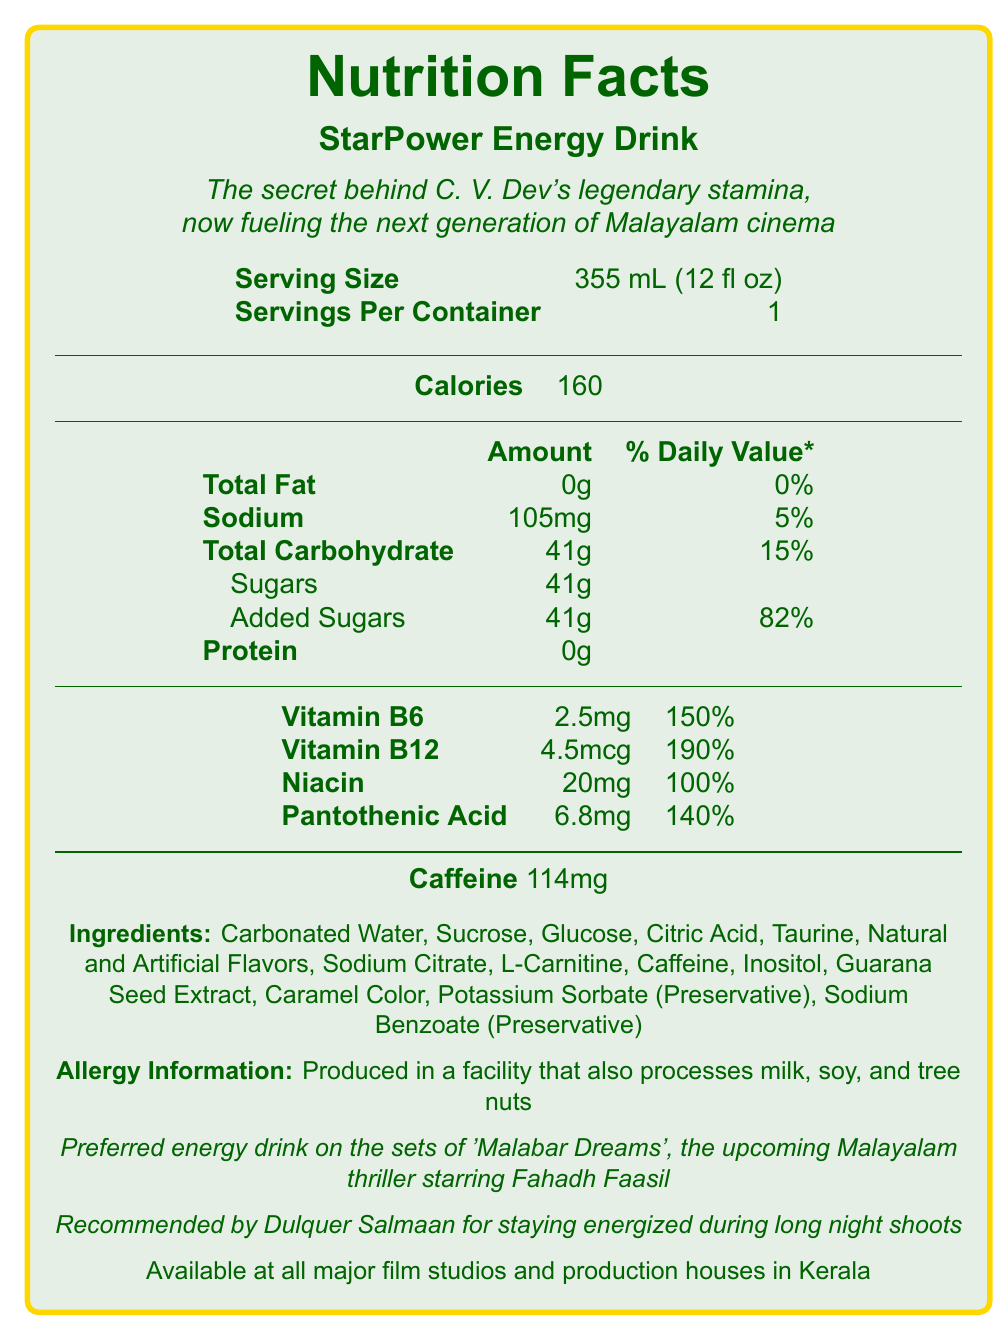what is the serving size of the StarPower Energy Drink? The serving size is mentioned under the section "Serving Size" in the document.
Answer: 355 mL (12 fl oz) how many calories are in one serving of StarPower Energy Drink? The calorie count is listed as "Calories: 160" in the document.
Answer: 160 calories what percentage of the daily value for sodium is in one serving? The sodium content shows "105mg" with a daily value of "5%" in the document.
Answer: 5% what is the amount of added sugars in the energy drink? Under the "Sugars" section, it specifies that "Added Sugars" amount to "41g".
Answer: 41g how much caffeine does one serving contain? The caffeine content is clearly listed as "Caffeine 114mg" in the document.
Answer: 114mg which Vitamin has the highest percentage of daily value? Vitamin B12 has the highest daily value percentage at "190%" in the list provided.
Answer: Vitamin B12 which of the following ingredients are preservatives? A. Taurine B. Potassium Sorbate C. L-Carnitine D. Inositol The document lists Potassium Sorbate as a preservative, under "Ingredients".
Answer: B. Potassium Sorbate what is the main reason for the energy drink's popularity in the Malayalam film industry? A. It's affordable B. Preferred on the sets of 'Malabar Dreams' C. Endorsed by a dietitian D. Available in every supermarket The document states the energy drink is "Preferred on the sets of 'Malabar Dreams'" and also endorsed by Dulquer Salmaan, making it popular.
Answer: B. Preferred on the sets of 'Malabar Dreams' is the StarPower Energy Drink recommended by a celebrity? The document mentions that it is "Recommended by Dulquer Salmaan for staying energized during long night shoots".
Answer: Yes summarize the main features and information of the StarPower Energy Drink. This summary encapsulates the essential details and unique features of the energy drink, emphasizing its popularity in the Malayalam film industry, nutritional content, ingredients, and allergy information.
Answer: The StarPower Energy Drink is a popular choice among filmmakers in Kerala, preferred on the sets of 'Malabar Dreams' and recommended by Dulquer Salmaan. The drink provides 160 calories per 355 mL serving and contains 0g total fat, 105mg sodium, 41g total carbohydrates, and 0g protein. It also contains 114mg of caffeine and a variety of vitamins and minerals, such as Vitamin B6, B12, Niacin, and Pantothenic Acid. The ingredients include carbonated water, sucrose, glucose, citric acid, among others. It is produced in a facility that processes milk, soy, and tree nuts. is the energy drink suitable for people with a milk allergy? The document states that the drink is produced in a facility that processes milk, which means there is a risk of cross-contamination, but it doesn't specify if the drink itself contains milk. Without this information, the suitability for those with a milk allergy cannot be determined.
Answer: Cannot be determined 